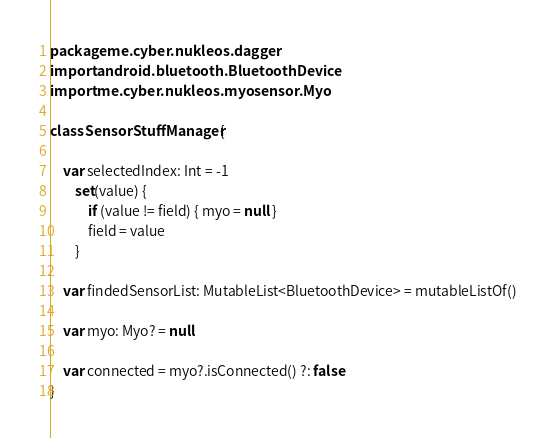Convert code to text. <code><loc_0><loc_0><loc_500><loc_500><_Kotlin_>package me.cyber.nukleos.dagger
import android.bluetooth.BluetoothDevice
import me.cyber.nukleos.myosensor.Myo

class SensorStuffManager {

    var selectedIndex: Int = -1
        set(value) {
            if (value != field) { myo = null }
            field = value
        }

    var findedSensorList: MutableList<BluetoothDevice> = mutableListOf()

    var myo: Myo? = null

    var connected = myo?.isConnected() ?: false
}</code> 